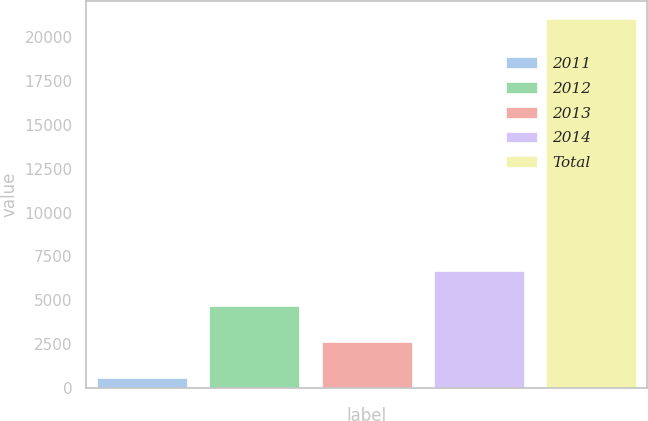Convert chart to OTSL. <chart><loc_0><loc_0><loc_500><loc_500><bar_chart><fcel>2011<fcel>2012<fcel>2013<fcel>2014<fcel>Total<nl><fcel>546<fcel>4644.2<fcel>2595.1<fcel>6693.3<fcel>21037<nl></chart> 